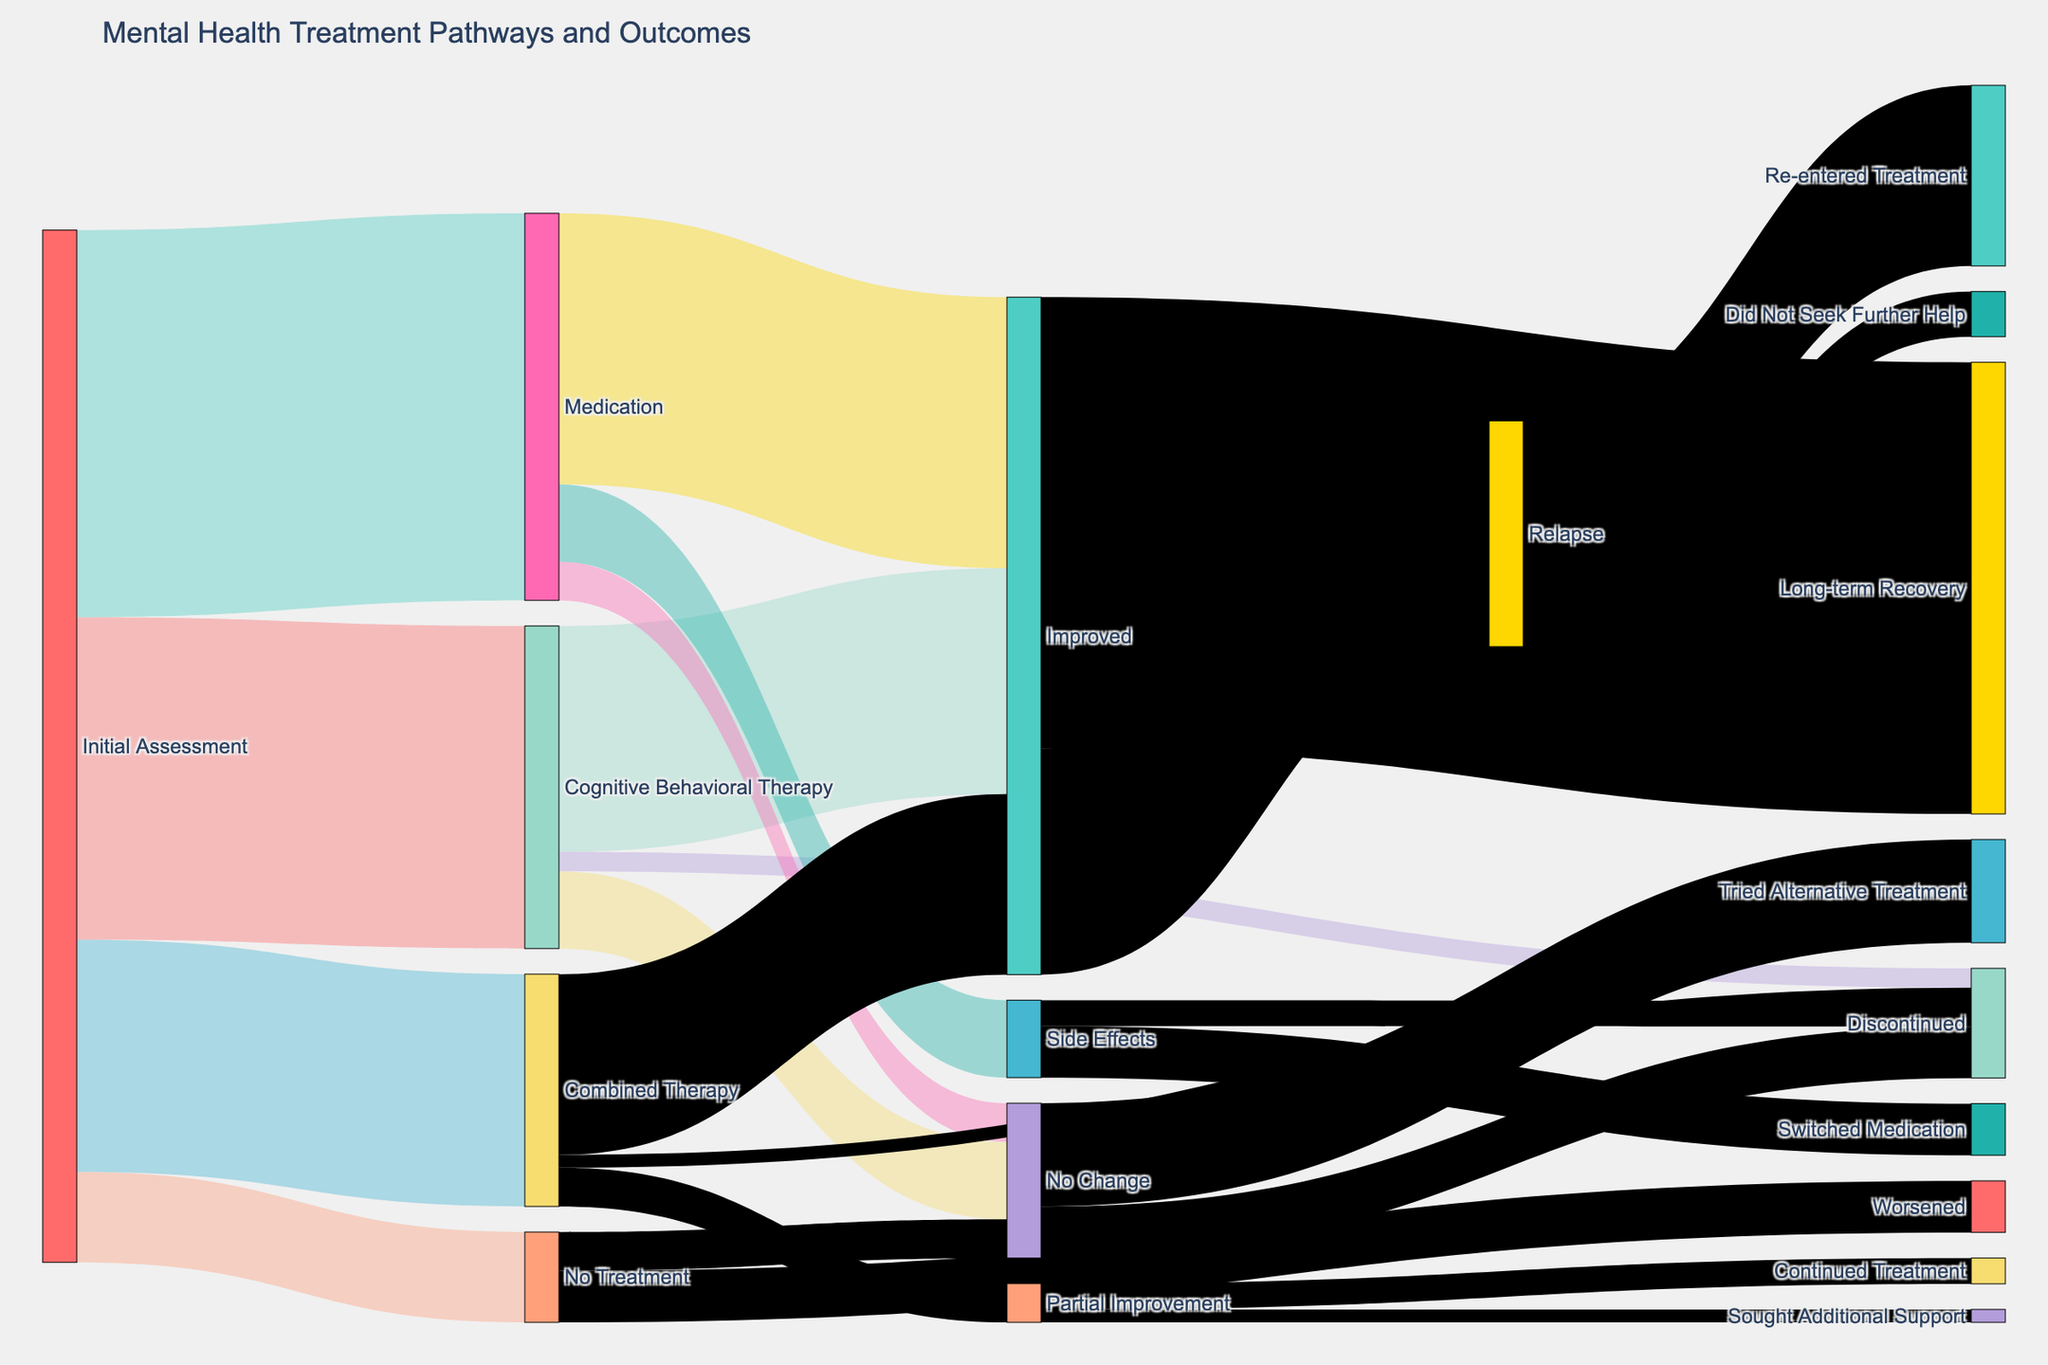What is the title of the Sankey diagram? The title is typically located at the top of the chart. It's printed in a larger font to capture attention. Here, we can directly observe it on top of the diagram.
Answer: Mental Health Treatment Pathways and Outcomes How many people discontinued treatment from Medication due to Side Effects? Look for the link flowing from the "Side Effects" node to the "Discontinued" node and note the value associated with it, which indicates the number of people.
Answer: 200 What is the total number of patients that showed improvement after receiving some form of treatment? Sum up all the values leading to the "Improved" node from different treatment options: Cognitive Behavioral Therapy (1750), Medication (2100), and Combined Therapy (1400).
Answer: 5250 Which treatment pathway resulted in the highest number of people showing improvement? Compare the outflow values leading to "Improved" from various treatments: Cognitive Behavioral Therapy (1750), Medication (2100), and Combined Therapy (1400). Identify the highest value.
Answer: Medication What is the sum of people who had no change in their condition from each treatment option? Summing the values linked to “No Change” from different treatment: Cognitive Behavioral Therapy (600), Medication (300), and No Treatment (300).
Answer: 1200 How many people worsened after opting for no treatment? Locate the link flowing from "No Treatment" to "Worsened" and identify the value associated with it.
Answer: 400 What portion of those who improved experienced a relapse? Compare the value of the link moving from "Improved" to "Relapse" (1750) to the total number of people who improved (5250). Use the formula (number of relapses / total improvements) * 100%.
Answer: 33.33% Between Cognitive Behavioral Therapy and Combined Therapy, which has a higher rate of discontinuation? Compare the discontinuation values from the two treatments: Cognitive Behavioral Therapy (150) and Combined Therapy (100).
Answer: Cognitive Behavioral Therapy What percentage of people who experienced Side Effects switched their medication? Calculate the proportion by dividing the number of people who switched medication (400) by the total number experiencing side effects (600). Multiply by 100 to get the percentage.
Answer: 66.67% How many people sought additional support after experiencing partial improvement from Combined Therapy? Find the value linked from "Partial Improvement" under Combined Therapy to "Sought Additional Support."
Answer: 100 Which node has the least number of individuals flowing into it? Examine the values leading to each node and determine the smallest one.
Answer: No Treatment 